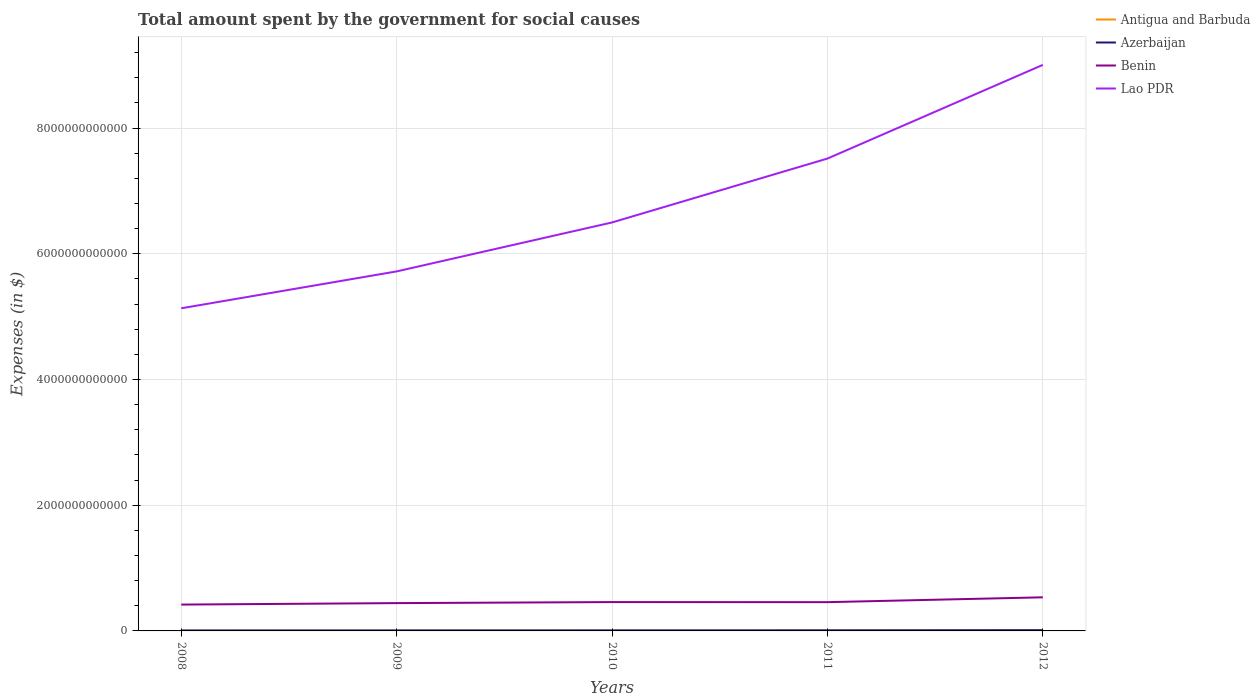Is the number of lines equal to the number of legend labels?
Ensure brevity in your answer.  Yes. Across all years, what is the maximum amount spent for social causes by the government in Antigua and Barbuda?
Give a very brief answer. 6.72e+08. In which year was the amount spent for social causes by the government in Antigua and Barbuda maximum?
Provide a short and direct response. 2012. What is the total amount spent for social causes by the government in Azerbaijan in the graph?
Provide a succinct answer. -3.93e+09. What is the difference between the highest and the second highest amount spent for social causes by the government in Benin?
Ensure brevity in your answer.  1.16e+11. What is the difference between the highest and the lowest amount spent for social causes by the government in Antigua and Barbuda?
Provide a short and direct response. 2. What is the difference between two consecutive major ticks on the Y-axis?
Make the answer very short. 2.00e+12. How are the legend labels stacked?
Your answer should be compact. Vertical. What is the title of the graph?
Offer a terse response. Total amount spent by the government for social causes. Does "Latin America(developing only)" appear as one of the legend labels in the graph?
Give a very brief answer. No. What is the label or title of the Y-axis?
Provide a short and direct response. Expenses (in $). What is the Expenses (in $) of Antigua and Barbuda in 2008?
Give a very brief answer. 7.66e+08. What is the Expenses (in $) of Azerbaijan in 2008?
Ensure brevity in your answer.  7.43e+09. What is the Expenses (in $) in Benin in 2008?
Keep it short and to the point. 4.19e+11. What is the Expenses (in $) of Lao PDR in 2008?
Keep it short and to the point. 5.13e+12. What is the Expenses (in $) in Antigua and Barbuda in 2009?
Provide a short and direct response. 7.82e+08. What is the Expenses (in $) in Azerbaijan in 2009?
Give a very brief answer. 8.22e+09. What is the Expenses (in $) in Benin in 2009?
Provide a succinct answer. 4.43e+11. What is the Expenses (in $) of Lao PDR in 2009?
Provide a succinct answer. 5.72e+12. What is the Expenses (in $) of Antigua and Barbuda in 2010?
Give a very brief answer. 6.76e+08. What is the Expenses (in $) of Azerbaijan in 2010?
Offer a terse response. 8.86e+09. What is the Expenses (in $) in Benin in 2010?
Your response must be concise. 4.59e+11. What is the Expenses (in $) in Lao PDR in 2010?
Provide a succinct answer. 6.50e+12. What is the Expenses (in $) of Antigua and Barbuda in 2011?
Make the answer very short. 7.15e+08. What is the Expenses (in $) of Azerbaijan in 2011?
Offer a terse response. 9.62e+09. What is the Expenses (in $) in Benin in 2011?
Keep it short and to the point. 4.58e+11. What is the Expenses (in $) in Lao PDR in 2011?
Your answer should be very brief. 7.52e+12. What is the Expenses (in $) of Antigua and Barbuda in 2012?
Keep it short and to the point. 6.72e+08. What is the Expenses (in $) of Azerbaijan in 2012?
Give a very brief answer. 1.21e+1. What is the Expenses (in $) in Benin in 2012?
Your answer should be very brief. 5.35e+11. What is the Expenses (in $) in Lao PDR in 2012?
Offer a terse response. 9.01e+12. Across all years, what is the maximum Expenses (in $) of Antigua and Barbuda?
Keep it short and to the point. 7.82e+08. Across all years, what is the maximum Expenses (in $) in Azerbaijan?
Offer a terse response. 1.21e+1. Across all years, what is the maximum Expenses (in $) of Benin?
Ensure brevity in your answer.  5.35e+11. Across all years, what is the maximum Expenses (in $) in Lao PDR?
Make the answer very short. 9.01e+12. Across all years, what is the minimum Expenses (in $) of Antigua and Barbuda?
Offer a very short reply. 6.72e+08. Across all years, what is the minimum Expenses (in $) of Azerbaijan?
Give a very brief answer. 7.43e+09. Across all years, what is the minimum Expenses (in $) of Benin?
Make the answer very short. 4.19e+11. Across all years, what is the minimum Expenses (in $) in Lao PDR?
Offer a terse response. 5.13e+12. What is the total Expenses (in $) in Antigua and Barbuda in the graph?
Provide a short and direct response. 3.61e+09. What is the total Expenses (in $) in Azerbaijan in the graph?
Offer a terse response. 4.63e+1. What is the total Expenses (in $) in Benin in the graph?
Provide a succinct answer. 2.31e+12. What is the total Expenses (in $) of Lao PDR in the graph?
Provide a short and direct response. 3.39e+13. What is the difference between the Expenses (in $) of Antigua and Barbuda in 2008 and that in 2009?
Your answer should be very brief. -1.54e+07. What is the difference between the Expenses (in $) of Azerbaijan in 2008 and that in 2009?
Your answer should be very brief. -7.88e+08. What is the difference between the Expenses (in $) of Benin in 2008 and that in 2009?
Give a very brief answer. -2.35e+1. What is the difference between the Expenses (in $) in Lao PDR in 2008 and that in 2009?
Offer a terse response. -5.87e+11. What is the difference between the Expenses (in $) of Antigua and Barbuda in 2008 and that in 2010?
Keep it short and to the point. 9.01e+07. What is the difference between the Expenses (in $) of Azerbaijan in 2008 and that in 2010?
Offer a terse response. -1.44e+09. What is the difference between the Expenses (in $) in Benin in 2008 and that in 2010?
Your answer should be compact. -3.99e+1. What is the difference between the Expenses (in $) in Lao PDR in 2008 and that in 2010?
Your answer should be compact. -1.37e+12. What is the difference between the Expenses (in $) of Antigua and Barbuda in 2008 and that in 2011?
Your answer should be very brief. 5.16e+07. What is the difference between the Expenses (in $) of Azerbaijan in 2008 and that in 2011?
Your response must be concise. -2.20e+09. What is the difference between the Expenses (in $) in Benin in 2008 and that in 2011?
Your answer should be very brief. -3.85e+1. What is the difference between the Expenses (in $) in Lao PDR in 2008 and that in 2011?
Keep it short and to the point. -2.38e+12. What is the difference between the Expenses (in $) in Antigua and Barbuda in 2008 and that in 2012?
Provide a short and direct response. 9.48e+07. What is the difference between the Expenses (in $) in Azerbaijan in 2008 and that in 2012?
Your response must be concise. -4.72e+09. What is the difference between the Expenses (in $) in Benin in 2008 and that in 2012?
Make the answer very short. -1.16e+11. What is the difference between the Expenses (in $) in Lao PDR in 2008 and that in 2012?
Give a very brief answer. -3.87e+12. What is the difference between the Expenses (in $) of Antigua and Barbuda in 2009 and that in 2010?
Give a very brief answer. 1.06e+08. What is the difference between the Expenses (in $) in Azerbaijan in 2009 and that in 2010?
Your response must be concise. -6.47e+08. What is the difference between the Expenses (in $) of Benin in 2009 and that in 2010?
Give a very brief answer. -1.64e+1. What is the difference between the Expenses (in $) in Lao PDR in 2009 and that in 2010?
Offer a terse response. -7.79e+11. What is the difference between the Expenses (in $) of Antigua and Barbuda in 2009 and that in 2011?
Offer a terse response. 6.70e+07. What is the difference between the Expenses (in $) of Azerbaijan in 2009 and that in 2011?
Give a very brief answer. -1.41e+09. What is the difference between the Expenses (in $) in Benin in 2009 and that in 2011?
Make the answer very short. -1.50e+1. What is the difference between the Expenses (in $) in Lao PDR in 2009 and that in 2011?
Your answer should be very brief. -1.80e+12. What is the difference between the Expenses (in $) of Antigua and Barbuda in 2009 and that in 2012?
Your response must be concise. 1.10e+08. What is the difference between the Expenses (in $) in Azerbaijan in 2009 and that in 2012?
Your answer should be very brief. -3.93e+09. What is the difference between the Expenses (in $) in Benin in 2009 and that in 2012?
Offer a terse response. -9.20e+1. What is the difference between the Expenses (in $) in Lao PDR in 2009 and that in 2012?
Your response must be concise. -3.29e+12. What is the difference between the Expenses (in $) in Antigua and Barbuda in 2010 and that in 2011?
Give a very brief answer. -3.85e+07. What is the difference between the Expenses (in $) of Azerbaijan in 2010 and that in 2011?
Give a very brief answer. -7.60e+08. What is the difference between the Expenses (in $) in Benin in 2010 and that in 2011?
Your response must be concise. 1.35e+09. What is the difference between the Expenses (in $) of Lao PDR in 2010 and that in 2011?
Ensure brevity in your answer.  -1.02e+12. What is the difference between the Expenses (in $) of Antigua and Barbuda in 2010 and that in 2012?
Offer a terse response. 4.70e+06. What is the difference between the Expenses (in $) in Azerbaijan in 2010 and that in 2012?
Give a very brief answer. -3.28e+09. What is the difference between the Expenses (in $) of Benin in 2010 and that in 2012?
Keep it short and to the point. -7.57e+1. What is the difference between the Expenses (in $) of Lao PDR in 2010 and that in 2012?
Provide a short and direct response. -2.51e+12. What is the difference between the Expenses (in $) in Antigua and Barbuda in 2011 and that in 2012?
Make the answer very short. 4.32e+07. What is the difference between the Expenses (in $) in Azerbaijan in 2011 and that in 2012?
Make the answer very short. -2.52e+09. What is the difference between the Expenses (in $) of Benin in 2011 and that in 2012?
Your response must be concise. -7.70e+1. What is the difference between the Expenses (in $) of Lao PDR in 2011 and that in 2012?
Offer a terse response. -1.49e+12. What is the difference between the Expenses (in $) in Antigua and Barbuda in 2008 and the Expenses (in $) in Azerbaijan in 2009?
Your answer should be compact. -7.45e+09. What is the difference between the Expenses (in $) of Antigua and Barbuda in 2008 and the Expenses (in $) of Benin in 2009?
Your answer should be very brief. -4.42e+11. What is the difference between the Expenses (in $) in Antigua and Barbuda in 2008 and the Expenses (in $) in Lao PDR in 2009?
Keep it short and to the point. -5.72e+12. What is the difference between the Expenses (in $) in Azerbaijan in 2008 and the Expenses (in $) in Benin in 2009?
Provide a succinct answer. -4.35e+11. What is the difference between the Expenses (in $) of Azerbaijan in 2008 and the Expenses (in $) of Lao PDR in 2009?
Provide a short and direct response. -5.71e+12. What is the difference between the Expenses (in $) in Benin in 2008 and the Expenses (in $) in Lao PDR in 2009?
Ensure brevity in your answer.  -5.30e+12. What is the difference between the Expenses (in $) of Antigua and Barbuda in 2008 and the Expenses (in $) of Azerbaijan in 2010?
Provide a succinct answer. -8.10e+09. What is the difference between the Expenses (in $) in Antigua and Barbuda in 2008 and the Expenses (in $) in Benin in 2010?
Your answer should be very brief. -4.58e+11. What is the difference between the Expenses (in $) of Antigua and Barbuda in 2008 and the Expenses (in $) of Lao PDR in 2010?
Your answer should be very brief. -6.50e+12. What is the difference between the Expenses (in $) in Azerbaijan in 2008 and the Expenses (in $) in Benin in 2010?
Provide a succinct answer. -4.52e+11. What is the difference between the Expenses (in $) of Azerbaijan in 2008 and the Expenses (in $) of Lao PDR in 2010?
Your response must be concise. -6.49e+12. What is the difference between the Expenses (in $) of Benin in 2008 and the Expenses (in $) of Lao PDR in 2010?
Provide a succinct answer. -6.08e+12. What is the difference between the Expenses (in $) in Antigua and Barbuda in 2008 and the Expenses (in $) in Azerbaijan in 2011?
Your response must be concise. -8.86e+09. What is the difference between the Expenses (in $) of Antigua and Barbuda in 2008 and the Expenses (in $) of Benin in 2011?
Ensure brevity in your answer.  -4.57e+11. What is the difference between the Expenses (in $) of Antigua and Barbuda in 2008 and the Expenses (in $) of Lao PDR in 2011?
Provide a short and direct response. -7.52e+12. What is the difference between the Expenses (in $) of Azerbaijan in 2008 and the Expenses (in $) of Benin in 2011?
Provide a short and direct response. -4.50e+11. What is the difference between the Expenses (in $) of Azerbaijan in 2008 and the Expenses (in $) of Lao PDR in 2011?
Offer a very short reply. -7.51e+12. What is the difference between the Expenses (in $) of Benin in 2008 and the Expenses (in $) of Lao PDR in 2011?
Offer a terse response. -7.10e+12. What is the difference between the Expenses (in $) of Antigua and Barbuda in 2008 and the Expenses (in $) of Azerbaijan in 2012?
Ensure brevity in your answer.  -1.14e+1. What is the difference between the Expenses (in $) in Antigua and Barbuda in 2008 and the Expenses (in $) in Benin in 2012?
Your answer should be very brief. -5.34e+11. What is the difference between the Expenses (in $) of Antigua and Barbuda in 2008 and the Expenses (in $) of Lao PDR in 2012?
Offer a very short reply. -9.01e+12. What is the difference between the Expenses (in $) in Azerbaijan in 2008 and the Expenses (in $) in Benin in 2012?
Offer a very short reply. -5.27e+11. What is the difference between the Expenses (in $) of Azerbaijan in 2008 and the Expenses (in $) of Lao PDR in 2012?
Make the answer very short. -9.00e+12. What is the difference between the Expenses (in $) of Benin in 2008 and the Expenses (in $) of Lao PDR in 2012?
Offer a very short reply. -8.59e+12. What is the difference between the Expenses (in $) of Antigua and Barbuda in 2009 and the Expenses (in $) of Azerbaijan in 2010?
Offer a terse response. -8.08e+09. What is the difference between the Expenses (in $) of Antigua and Barbuda in 2009 and the Expenses (in $) of Benin in 2010?
Offer a terse response. -4.58e+11. What is the difference between the Expenses (in $) of Antigua and Barbuda in 2009 and the Expenses (in $) of Lao PDR in 2010?
Your response must be concise. -6.50e+12. What is the difference between the Expenses (in $) in Azerbaijan in 2009 and the Expenses (in $) in Benin in 2010?
Offer a very short reply. -4.51e+11. What is the difference between the Expenses (in $) of Azerbaijan in 2009 and the Expenses (in $) of Lao PDR in 2010?
Offer a very short reply. -6.49e+12. What is the difference between the Expenses (in $) in Benin in 2009 and the Expenses (in $) in Lao PDR in 2010?
Provide a succinct answer. -6.06e+12. What is the difference between the Expenses (in $) in Antigua and Barbuda in 2009 and the Expenses (in $) in Azerbaijan in 2011?
Keep it short and to the point. -8.84e+09. What is the difference between the Expenses (in $) in Antigua and Barbuda in 2009 and the Expenses (in $) in Benin in 2011?
Provide a succinct answer. -4.57e+11. What is the difference between the Expenses (in $) of Antigua and Barbuda in 2009 and the Expenses (in $) of Lao PDR in 2011?
Your answer should be very brief. -7.52e+12. What is the difference between the Expenses (in $) of Azerbaijan in 2009 and the Expenses (in $) of Benin in 2011?
Offer a terse response. -4.49e+11. What is the difference between the Expenses (in $) of Azerbaijan in 2009 and the Expenses (in $) of Lao PDR in 2011?
Keep it short and to the point. -7.51e+12. What is the difference between the Expenses (in $) in Benin in 2009 and the Expenses (in $) in Lao PDR in 2011?
Offer a terse response. -7.07e+12. What is the difference between the Expenses (in $) in Antigua and Barbuda in 2009 and the Expenses (in $) in Azerbaijan in 2012?
Offer a terse response. -1.14e+1. What is the difference between the Expenses (in $) of Antigua and Barbuda in 2009 and the Expenses (in $) of Benin in 2012?
Your answer should be compact. -5.34e+11. What is the difference between the Expenses (in $) of Antigua and Barbuda in 2009 and the Expenses (in $) of Lao PDR in 2012?
Offer a very short reply. -9.01e+12. What is the difference between the Expenses (in $) in Azerbaijan in 2009 and the Expenses (in $) in Benin in 2012?
Give a very brief answer. -5.26e+11. What is the difference between the Expenses (in $) in Azerbaijan in 2009 and the Expenses (in $) in Lao PDR in 2012?
Provide a short and direct response. -9.00e+12. What is the difference between the Expenses (in $) of Benin in 2009 and the Expenses (in $) of Lao PDR in 2012?
Make the answer very short. -8.56e+12. What is the difference between the Expenses (in $) of Antigua and Barbuda in 2010 and the Expenses (in $) of Azerbaijan in 2011?
Your answer should be very brief. -8.95e+09. What is the difference between the Expenses (in $) of Antigua and Barbuda in 2010 and the Expenses (in $) of Benin in 2011?
Offer a terse response. -4.57e+11. What is the difference between the Expenses (in $) in Antigua and Barbuda in 2010 and the Expenses (in $) in Lao PDR in 2011?
Your answer should be very brief. -7.52e+12. What is the difference between the Expenses (in $) in Azerbaijan in 2010 and the Expenses (in $) in Benin in 2011?
Make the answer very short. -4.49e+11. What is the difference between the Expenses (in $) in Azerbaijan in 2010 and the Expenses (in $) in Lao PDR in 2011?
Your answer should be very brief. -7.51e+12. What is the difference between the Expenses (in $) of Benin in 2010 and the Expenses (in $) of Lao PDR in 2011?
Offer a terse response. -7.06e+12. What is the difference between the Expenses (in $) of Antigua and Barbuda in 2010 and the Expenses (in $) of Azerbaijan in 2012?
Provide a succinct answer. -1.15e+1. What is the difference between the Expenses (in $) in Antigua and Barbuda in 2010 and the Expenses (in $) in Benin in 2012?
Offer a very short reply. -5.34e+11. What is the difference between the Expenses (in $) of Antigua and Barbuda in 2010 and the Expenses (in $) of Lao PDR in 2012?
Make the answer very short. -9.01e+12. What is the difference between the Expenses (in $) of Azerbaijan in 2010 and the Expenses (in $) of Benin in 2012?
Your answer should be very brief. -5.26e+11. What is the difference between the Expenses (in $) in Azerbaijan in 2010 and the Expenses (in $) in Lao PDR in 2012?
Keep it short and to the point. -9.00e+12. What is the difference between the Expenses (in $) of Benin in 2010 and the Expenses (in $) of Lao PDR in 2012?
Give a very brief answer. -8.55e+12. What is the difference between the Expenses (in $) in Antigua and Barbuda in 2011 and the Expenses (in $) in Azerbaijan in 2012?
Your response must be concise. -1.14e+1. What is the difference between the Expenses (in $) of Antigua and Barbuda in 2011 and the Expenses (in $) of Benin in 2012?
Your answer should be compact. -5.34e+11. What is the difference between the Expenses (in $) in Antigua and Barbuda in 2011 and the Expenses (in $) in Lao PDR in 2012?
Provide a short and direct response. -9.01e+12. What is the difference between the Expenses (in $) of Azerbaijan in 2011 and the Expenses (in $) of Benin in 2012?
Your response must be concise. -5.25e+11. What is the difference between the Expenses (in $) in Azerbaijan in 2011 and the Expenses (in $) in Lao PDR in 2012?
Your answer should be very brief. -9.00e+12. What is the difference between the Expenses (in $) of Benin in 2011 and the Expenses (in $) of Lao PDR in 2012?
Offer a very short reply. -8.55e+12. What is the average Expenses (in $) in Antigua and Barbuda per year?
Keep it short and to the point. 7.22e+08. What is the average Expenses (in $) in Azerbaijan per year?
Make the answer very short. 9.26e+09. What is the average Expenses (in $) in Benin per year?
Keep it short and to the point. 4.63e+11. What is the average Expenses (in $) of Lao PDR per year?
Make the answer very short. 6.78e+12. In the year 2008, what is the difference between the Expenses (in $) in Antigua and Barbuda and Expenses (in $) in Azerbaijan?
Your answer should be compact. -6.66e+09. In the year 2008, what is the difference between the Expenses (in $) in Antigua and Barbuda and Expenses (in $) in Benin?
Give a very brief answer. -4.18e+11. In the year 2008, what is the difference between the Expenses (in $) of Antigua and Barbuda and Expenses (in $) of Lao PDR?
Provide a short and direct response. -5.13e+12. In the year 2008, what is the difference between the Expenses (in $) in Azerbaijan and Expenses (in $) in Benin?
Provide a succinct answer. -4.12e+11. In the year 2008, what is the difference between the Expenses (in $) of Azerbaijan and Expenses (in $) of Lao PDR?
Your answer should be compact. -5.13e+12. In the year 2008, what is the difference between the Expenses (in $) of Benin and Expenses (in $) of Lao PDR?
Offer a terse response. -4.71e+12. In the year 2009, what is the difference between the Expenses (in $) in Antigua and Barbuda and Expenses (in $) in Azerbaijan?
Offer a terse response. -7.43e+09. In the year 2009, what is the difference between the Expenses (in $) in Antigua and Barbuda and Expenses (in $) in Benin?
Ensure brevity in your answer.  -4.42e+11. In the year 2009, what is the difference between the Expenses (in $) of Antigua and Barbuda and Expenses (in $) of Lao PDR?
Provide a short and direct response. -5.72e+12. In the year 2009, what is the difference between the Expenses (in $) in Azerbaijan and Expenses (in $) in Benin?
Your answer should be compact. -4.34e+11. In the year 2009, what is the difference between the Expenses (in $) of Azerbaijan and Expenses (in $) of Lao PDR?
Give a very brief answer. -5.71e+12. In the year 2009, what is the difference between the Expenses (in $) in Benin and Expenses (in $) in Lao PDR?
Offer a very short reply. -5.28e+12. In the year 2010, what is the difference between the Expenses (in $) of Antigua and Barbuda and Expenses (in $) of Azerbaijan?
Provide a succinct answer. -8.19e+09. In the year 2010, what is the difference between the Expenses (in $) of Antigua and Barbuda and Expenses (in $) of Benin?
Provide a succinct answer. -4.58e+11. In the year 2010, what is the difference between the Expenses (in $) in Antigua and Barbuda and Expenses (in $) in Lao PDR?
Ensure brevity in your answer.  -6.50e+12. In the year 2010, what is the difference between the Expenses (in $) of Azerbaijan and Expenses (in $) of Benin?
Offer a terse response. -4.50e+11. In the year 2010, what is the difference between the Expenses (in $) of Azerbaijan and Expenses (in $) of Lao PDR?
Your answer should be compact. -6.49e+12. In the year 2010, what is the difference between the Expenses (in $) in Benin and Expenses (in $) in Lao PDR?
Offer a very short reply. -6.04e+12. In the year 2011, what is the difference between the Expenses (in $) of Antigua and Barbuda and Expenses (in $) of Azerbaijan?
Your answer should be compact. -8.91e+09. In the year 2011, what is the difference between the Expenses (in $) in Antigua and Barbuda and Expenses (in $) in Benin?
Provide a short and direct response. -4.57e+11. In the year 2011, what is the difference between the Expenses (in $) of Antigua and Barbuda and Expenses (in $) of Lao PDR?
Your response must be concise. -7.52e+12. In the year 2011, what is the difference between the Expenses (in $) in Azerbaijan and Expenses (in $) in Benin?
Provide a short and direct response. -4.48e+11. In the year 2011, what is the difference between the Expenses (in $) in Azerbaijan and Expenses (in $) in Lao PDR?
Keep it short and to the point. -7.51e+12. In the year 2011, what is the difference between the Expenses (in $) in Benin and Expenses (in $) in Lao PDR?
Provide a succinct answer. -7.06e+12. In the year 2012, what is the difference between the Expenses (in $) in Antigua and Barbuda and Expenses (in $) in Azerbaijan?
Your answer should be very brief. -1.15e+1. In the year 2012, what is the difference between the Expenses (in $) in Antigua and Barbuda and Expenses (in $) in Benin?
Ensure brevity in your answer.  -5.34e+11. In the year 2012, what is the difference between the Expenses (in $) in Antigua and Barbuda and Expenses (in $) in Lao PDR?
Your answer should be compact. -9.01e+12. In the year 2012, what is the difference between the Expenses (in $) in Azerbaijan and Expenses (in $) in Benin?
Provide a succinct answer. -5.23e+11. In the year 2012, what is the difference between the Expenses (in $) of Azerbaijan and Expenses (in $) of Lao PDR?
Offer a terse response. -8.99e+12. In the year 2012, what is the difference between the Expenses (in $) of Benin and Expenses (in $) of Lao PDR?
Ensure brevity in your answer.  -8.47e+12. What is the ratio of the Expenses (in $) of Antigua and Barbuda in 2008 to that in 2009?
Provide a succinct answer. 0.98. What is the ratio of the Expenses (in $) of Azerbaijan in 2008 to that in 2009?
Your response must be concise. 0.9. What is the ratio of the Expenses (in $) of Benin in 2008 to that in 2009?
Offer a very short reply. 0.95. What is the ratio of the Expenses (in $) in Lao PDR in 2008 to that in 2009?
Your response must be concise. 0.9. What is the ratio of the Expenses (in $) in Antigua and Barbuda in 2008 to that in 2010?
Your answer should be compact. 1.13. What is the ratio of the Expenses (in $) in Azerbaijan in 2008 to that in 2010?
Provide a short and direct response. 0.84. What is the ratio of the Expenses (in $) in Benin in 2008 to that in 2010?
Provide a short and direct response. 0.91. What is the ratio of the Expenses (in $) of Lao PDR in 2008 to that in 2010?
Make the answer very short. 0.79. What is the ratio of the Expenses (in $) of Antigua and Barbuda in 2008 to that in 2011?
Provide a short and direct response. 1.07. What is the ratio of the Expenses (in $) in Azerbaijan in 2008 to that in 2011?
Offer a terse response. 0.77. What is the ratio of the Expenses (in $) of Benin in 2008 to that in 2011?
Your response must be concise. 0.92. What is the ratio of the Expenses (in $) in Lao PDR in 2008 to that in 2011?
Your answer should be very brief. 0.68. What is the ratio of the Expenses (in $) of Antigua and Barbuda in 2008 to that in 2012?
Offer a very short reply. 1.14. What is the ratio of the Expenses (in $) of Azerbaijan in 2008 to that in 2012?
Keep it short and to the point. 0.61. What is the ratio of the Expenses (in $) in Benin in 2008 to that in 2012?
Your response must be concise. 0.78. What is the ratio of the Expenses (in $) of Lao PDR in 2008 to that in 2012?
Provide a short and direct response. 0.57. What is the ratio of the Expenses (in $) in Antigua and Barbuda in 2009 to that in 2010?
Provide a succinct answer. 1.16. What is the ratio of the Expenses (in $) of Azerbaijan in 2009 to that in 2010?
Offer a very short reply. 0.93. What is the ratio of the Expenses (in $) in Benin in 2009 to that in 2010?
Keep it short and to the point. 0.96. What is the ratio of the Expenses (in $) of Lao PDR in 2009 to that in 2010?
Offer a very short reply. 0.88. What is the ratio of the Expenses (in $) in Antigua and Barbuda in 2009 to that in 2011?
Provide a short and direct response. 1.09. What is the ratio of the Expenses (in $) in Azerbaijan in 2009 to that in 2011?
Your answer should be very brief. 0.85. What is the ratio of the Expenses (in $) of Benin in 2009 to that in 2011?
Offer a very short reply. 0.97. What is the ratio of the Expenses (in $) in Lao PDR in 2009 to that in 2011?
Your answer should be compact. 0.76. What is the ratio of the Expenses (in $) of Antigua and Barbuda in 2009 to that in 2012?
Provide a succinct answer. 1.16. What is the ratio of the Expenses (in $) of Azerbaijan in 2009 to that in 2012?
Offer a terse response. 0.68. What is the ratio of the Expenses (in $) in Benin in 2009 to that in 2012?
Your response must be concise. 0.83. What is the ratio of the Expenses (in $) of Lao PDR in 2009 to that in 2012?
Offer a terse response. 0.64. What is the ratio of the Expenses (in $) in Antigua and Barbuda in 2010 to that in 2011?
Provide a short and direct response. 0.95. What is the ratio of the Expenses (in $) in Azerbaijan in 2010 to that in 2011?
Provide a succinct answer. 0.92. What is the ratio of the Expenses (in $) in Benin in 2010 to that in 2011?
Provide a short and direct response. 1. What is the ratio of the Expenses (in $) in Lao PDR in 2010 to that in 2011?
Ensure brevity in your answer.  0.86. What is the ratio of the Expenses (in $) in Antigua and Barbuda in 2010 to that in 2012?
Your answer should be compact. 1.01. What is the ratio of the Expenses (in $) in Azerbaijan in 2010 to that in 2012?
Ensure brevity in your answer.  0.73. What is the ratio of the Expenses (in $) of Benin in 2010 to that in 2012?
Your answer should be very brief. 0.86. What is the ratio of the Expenses (in $) in Lao PDR in 2010 to that in 2012?
Keep it short and to the point. 0.72. What is the ratio of the Expenses (in $) of Antigua and Barbuda in 2011 to that in 2012?
Your answer should be compact. 1.06. What is the ratio of the Expenses (in $) in Azerbaijan in 2011 to that in 2012?
Ensure brevity in your answer.  0.79. What is the ratio of the Expenses (in $) of Benin in 2011 to that in 2012?
Offer a very short reply. 0.86. What is the ratio of the Expenses (in $) of Lao PDR in 2011 to that in 2012?
Your answer should be compact. 0.83. What is the difference between the highest and the second highest Expenses (in $) of Antigua and Barbuda?
Provide a short and direct response. 1.54e+07. What is the difference between the highest and the second highest Expenses (in $) of Azerbaijan?
Ensure brevity in your answer.  2.52e+09. What is the difference between the highest and the second highest Expenses (in $) of Benin?
Your response must be concise. 7.57e+1. What is the difference between the highest and the second highest Expenses (in $) of Lao PDR?
Your response must be concise. 1.49e+12. What is the difference between the highest and the lowest Expenses (in $) of Antigua and Barbuda?
Ensure brevity in your answer.  1.10e+08. What is the difference between the highest and the lowest Expenses (in $) in Azerbaijan?
Keep it short and to the point. 4.72e+09. What is the difference between the highest and the lowest Expenses (in $) of Benin?
Provide a short and direct response. 1.16e+11. What is the difference between the highest and the lowest Expenses (in $) in Lao PDR?
Keep it short and to the point. 3.87e+12. 